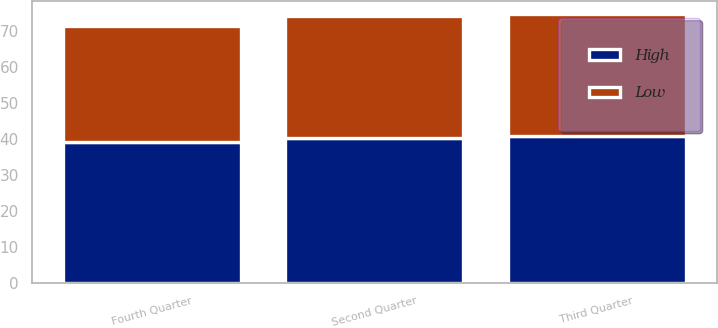Convert chart. <chart><loc_0><loc_0><loc_500><loc_500><stacked_bar_chart><ecel><fcel>Second Quarter<fcel>Third Quarter<fcel>Fourth Quarter<nl><fcel>High<fcel>40.35<fcel>40.8<fcel>39.11<nl><fcel>Low<fcel>33.93<fcel>33.94<fcel>32.56<nl></chart> 